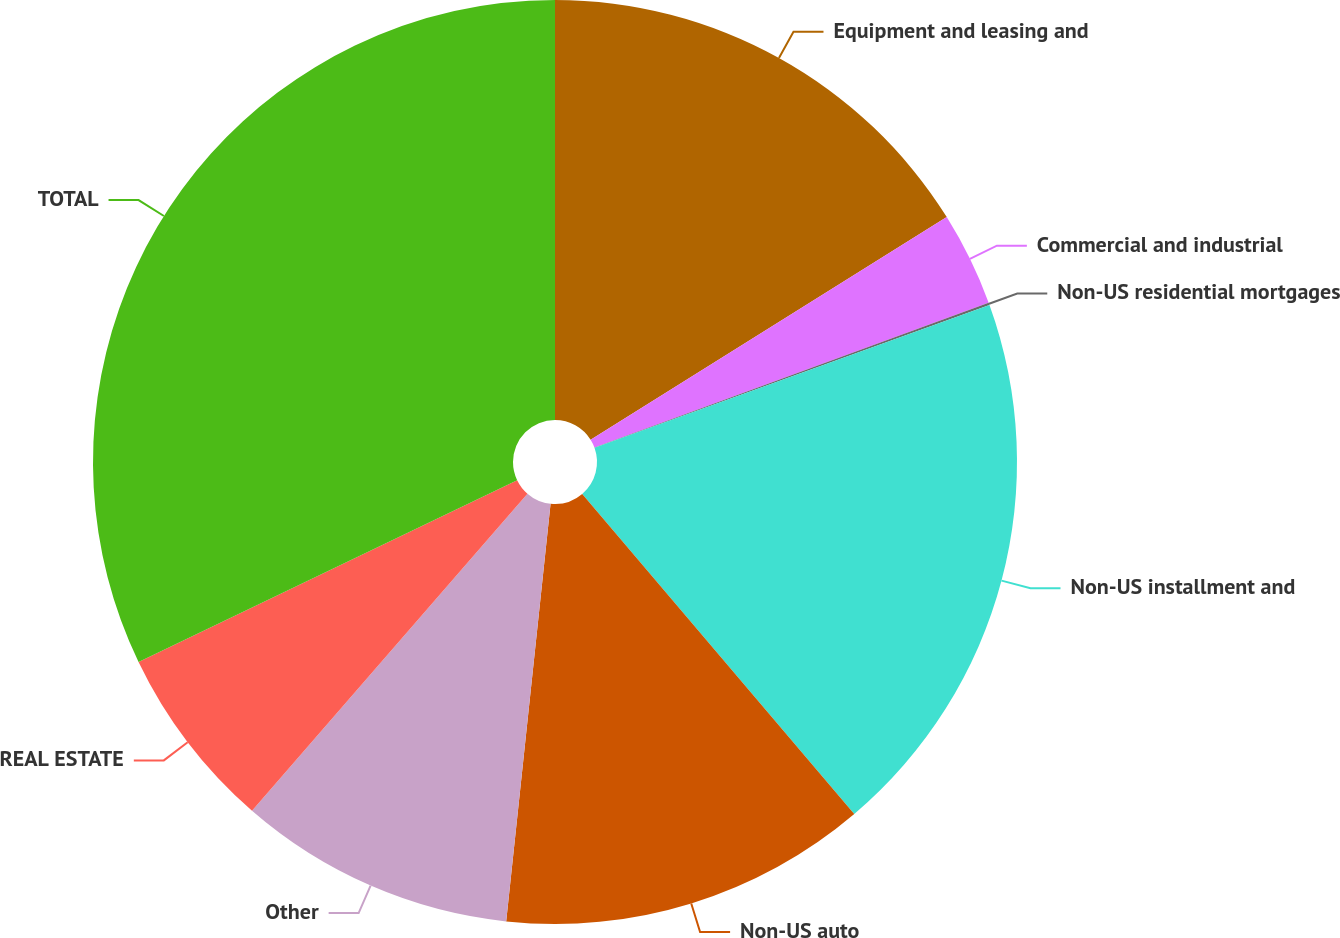Convert chart. <chart><loc_0><loc_0><loc_500><loc_500><pie_chart><fcel>Equipment and leasing and<fcel>Commercial and industrial<fcel>Non-US residential mortgages<fcel>Non-US installment and<fcel>Non-US auto<fcel>Other<fcel>REAL ESTATE<fcel>TOTAL<nl><fcel>16.11%<fcel>3.29%<fcel>0.08%<fcel>19.31%<fcel>12.9%<fcel>9.7%<fcel>6.49%<fcel>32.13%<nl></chart> 